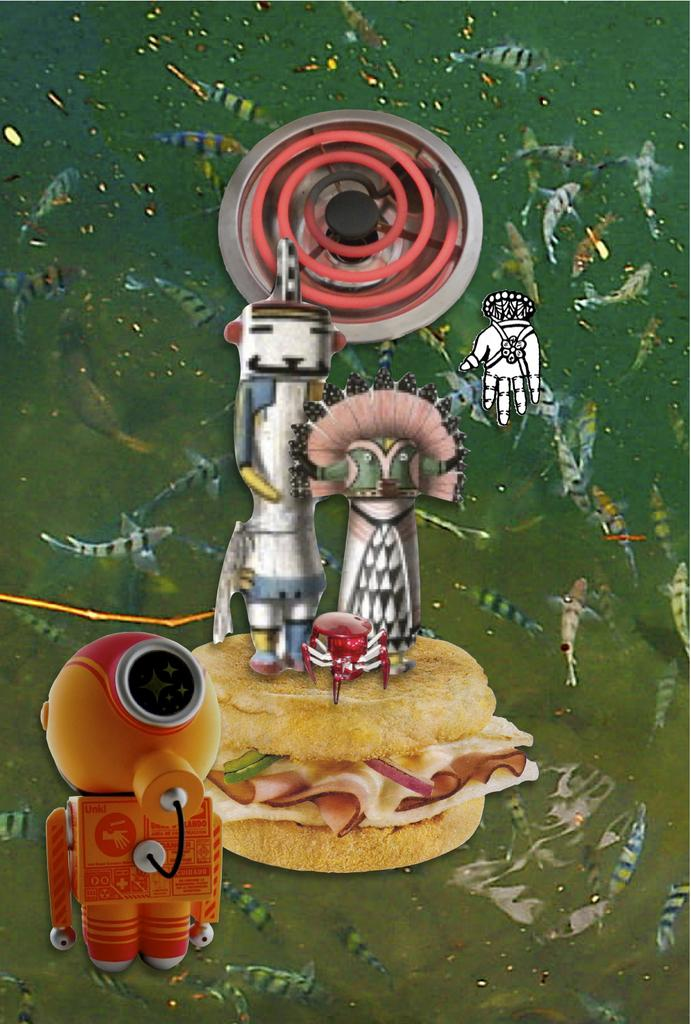What types of animated images can be seen in the picture? There are animated images of food, machines, and fishes in the picture. Can you describe the animated images of food in the picture? The animated images of food in the picture are not specified, but they are present. What other types of animated images are present in the picture? In addition to food and machines, there are animated images of fishes in the picture. What type of linen can be seen in the picture? There is no linen present in the picture; it only contains animated images of food, machines, and fishes. 